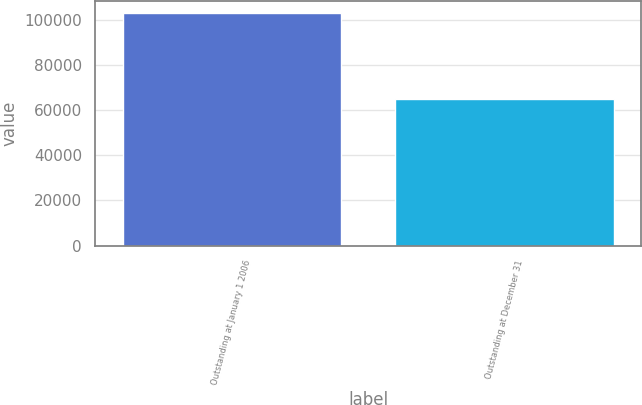Convert chart to OTSL. <chart><loc_0><loc_0><loc_500><loc_500><bar_chart><fcel>Outstanding at January 1 2006<fcel>Outstanding at December 31<nl><fcel>103283<fcel>65035<nl></chart> 